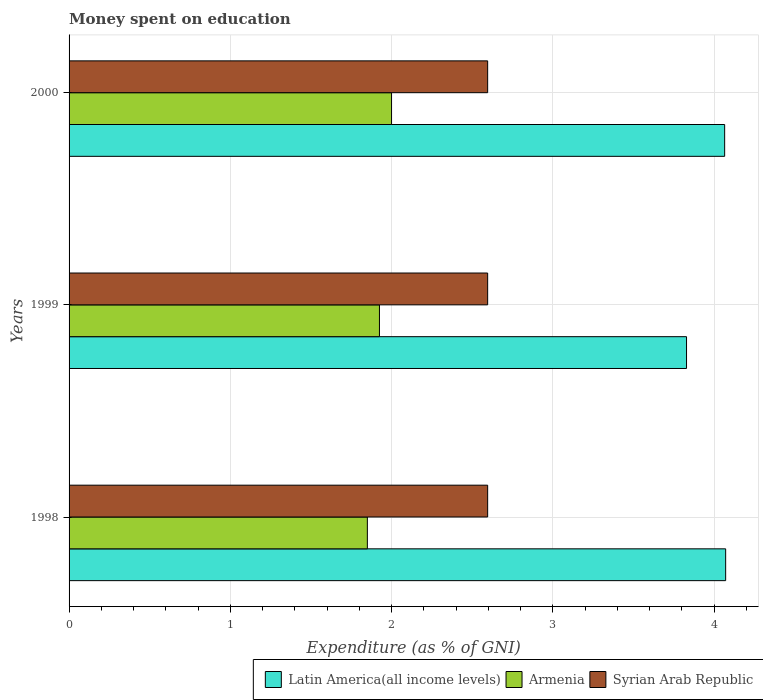How many different coloured bars are there?
Provide a short and direct response. 3. Are the number of bars on each tick of the Y-axis equal?
Make the answer very short. Yes. How many bars are there on the 3rd tick from the top?
Your answer should be very brief. 3. In how many cases, is the number of bars for a given year not equal to the number of legend labels?
Keep it short and to the point. 0. What is the amount of money spent on education in Syrian Arab Republic in 1998?
Your response must be concise. 2.6. Across all years, what is the maximum amount of money spent on education in Armenia?
Keep it short and to the point. 2. Across all years, what is the minimum amount of money spent on education in Latin America(all income levels)?
Offer a terse response. 3.83. In which year was the amount of money spent on education in Syrian Arab Republic minimum?
Your response must be concise. 1998. What is the total amount of money spent on education in Syrian Arab Republic in the graph?
Your answer should be compact. 7.79. What is the difference between the amount of money spent on education in Latin America(all income levels) in 1998 and that in 2000?
Your answer should be compact. 0.01. What is the difference between the amount of money spent on education in Latin America(all income levels) in 2000 and the amount of money spent on education in Armenia in 1998?
Provide a succinct answer. 2.22. What is the average amount of money spent on education in Armenia per year?
Make the answer very short. 1.92. In the year 1998, what is the difference between the amount of money spent on education in Syrian Arab Republic and amount of money spent on education in Latin America(all income levels)?
Make the answer very short. -1.48. Is the amount of money spent on education in Armenia in 1998 less than that in 2000?
Provide a short and direct response. Yes. What is the difference between the highest and the second highest amount of money spent on education in Armenia?
Offer a very short reply. 0.07. What is the difference between the highest and the lowest amount of money spent on education in Latin America(all income levels)?
Keep it short and to the point. 0.24. What does the 3rd bar from the top in 1999 represents?
Give a very brief answer. Latin America(all income levels). What does the 3rd bar from the bottom in 1999 represents?
Your answer should be very brief. Syrian Arab Republic. How many bars are there?
Your answer should be very brief. 9. How many years are there in the graph?
Your answer should be very brief. 3. What is the difference between two consecutive major ticks on the X-axis?
Your answer should be compact. 1. Are the values on the major ticks of X-axis written in scientific E-notation?
Your answer should be very brief. No. Does the graph contain any zero values?
Provide a short and direct response. No. Where does the legend appear in the graph?
Keep it short and to the point. Bottom right. What is the title of the graph?
Your answer should be compact. Money spent on education. Does "Mozambique" appear as one of the legend labels in the graph?
Offer a terse response. No. What is the label or title of the X-axis?
Your answer should be compact. Expenditure (as % of GNI). What is the label or title of the Y-axis?
Offer a very short reply. Years. What is the Expenditure (as % of GNI) of Latin America(all income levels) in 1998?
Provide a succinct answer. 4.07. What is the Expenditure (as % of GNI) of Armenia in 1998?
Ensure brevity in your answer.  1.85. What is the Expenditure (as % of GNI) of Syrian Arab Republic in 1998?
Keep it short and to the point. 2.6. What is the Expenditure (as % of GNI) in Latin America(all income levels) in 1999?
Your answer should be very brief. 3.83. What is the Expenditure (as % of GNI) of Armenia in 1999?
Provide a short and direct response. 1.92. What is the Expenditure (as % of GNI) in Syrian Arab Republic in 1999?
Keep it short and to the point. 2.6. What is the Expenditure (as % of GNI) of Latin America(all income levels) in 2000?
Offer a terse response. 4.07. What is the Expenditure (as % of GNI) of Armenia in 2000?
Keep it short and to the point. 2. What is the Expenditure (as % of GNI) in Syrian Arab Republic in 2000?
Your answer should be compact. 2.6. Across all years, what is the maximum Expenditure (as % of GNI) in Latin America(all income levels)?
Your response must be concise. 4.07. Across all years, what is the maximum Expenditure (as % of GNI) in Armenia?
Keep it short and to the point. 2. Across all years, what is the maximum Expenditure (as % of GNI) of Syrian Arab Republic?
Make the answer very short. 2.6. Across all years, what is the minimum Expenditure (as % of GNI) of Latin America(all income levels)?
Keep it short and to the point. 3.83. Across all years, what is the minimum Expenditure (as % of GNI) in Armenia?
Your answer should be very brief. 1.85. Across all years, what is the minimum Expenditure (as % of GNI) of Syrian Arab Republic?
Make the answer very short. 2.6. What is the total Expenditure (as % of GNI) of Latin America(all income levels) in the graph?
Provide a short and direct response. 11.97. What is the total Expenditure (as % of GNI) of Armenia in the graph?
Offer a very short reply. 5.78. What is the total Expenditure (as % of GNI) in Syrian Arab Republic in the graph?
Your response must be concise. 7.79. What is the difference between the Expenditure (as % of GNI) of Latin America(all income levels) in 1998 and that in 1999?
Keep it short and to the point. 0.24. What is the difference between the Expenditure (as % of GNI) of Armenia in 1998 and that in 1999?
Give a very brief answer. -0.07. What is the difference between the Expenditure (as % of GNI) in Latin America(all income levels) in 1998 and that in 2000?
Provide a succinct answer. 0.01. What is the difference between the Expenditure (as % of GNI) in Armenia in 1998 and that in 2000?
Your answer should be very brief. -0.15. What is the difference between the Expenditure (as % of GNI) of Latin America(all income levels) in 1999 and that in 2000?
Ensure brevity in your answer.  -0.24. What is the difference between the Expenditure (as % of GNI) in Armenia in 1999 and that in 2000?
Offer a very short reply. -0.07. What is the difference between the Expenditure (as % of GNI) of Latin America(all income levels) in 1998 and the Expenditure (as % of GNI) of Armenia in 1999?
Ensure brevity in your answer.  2.15. What is the difference between the Expenditure (as % of GNI) in Latin America(all income levels) in 1998 and the Expenditure (as % of GNI) in Syrian Arab Republic in 1999?
Your answer should be very brief. 1.48. What is the difference between the Expenditure (as % of GNI) of Armenia in 1998 and the Expenditure (as % of GNI) of Syrian Arab Republic in 1999?
Offer a terse response. -0.75. What is the difference between the Expenditure (as % of GNI) in Latin America(all income levels) in 1998 and the Expenditure (as % of GNI) in Armenia in 2000?
Offer a terse response. 2.07. What is the difference between the Expenditure (as % of GNI) in Latin America(all income levels) in 1998 and the Expenditure (as % of GNI) in Syrian Arab Republic in 2000?
Your response must be concise. 1.48. What is the difference between the Expenditure (as % of GNI) of Armenia in 1998 and the Expenditure (as % of GNI) of Syrian Arab Republic in 2000?
Give a very brief answer. -0.75. What is the difference between the Expenditure (as % of GNI) of Latin America(all income levels) in 1999 and the Expenditure (as % of GNI) of Armenia in 2000?
Provide a succinct answer. 1.83. What is the difference between the Expenditure (as % of GNI) of Latin America(all income levels) in 1999 and the Expenditure (as % of GNI) of Syrian Arab Republic in 2000?
Provide a short and direct response. 1.23. What is the difference between the Expenditure (as % of GNI) in Armenia in 1999 and the Expenditure (as % of GNI) in Syrian Arab Republic in 2000?
Your response must be concise. -0.67. What is the average Expenditure (as % of GNI) of Latin America(all income levels) per year?
Keep it short and to the point. 3.99. What is the average Expenditure (as % of GNI) of Armenia per year?
Keep it short and to the point. 1.93. What is the average Expenditure (as % of GNI) in Syrian Arab Republic per year?
Your answer should be compact. 2.6. In the year 1998, what is the difference between the Expenditure (as % of GNI) of Latin America(all income levels) and Expenditure (as % of GNI) of Armenia?
Your answer should be very brief. 2.22. In the year 1998, what is the difference between the Expenditure (as % of GNI) in Latin America(all income levels) and Expenditure (as % of GNI) in Syrian Arab Republic?
Your answer should be compact. 1.48. In the year 1998, what is the difference between the Expenditure (as % of GNI) in Armenia and Expenditure (as % of GNI) in Syrian Arab Republic?
Offer a very short reply. -0.75. In the year 1999, what is the difference between the Expenditure (as % of GNI) of Latin America(all income levels) and Expenditure (as % of GNI) of Armenia?
Ensure brevity in your answer.  1.9. In the year 1999, what is the difference between the Expenditure (as % of GNI) in Latin America(all income levels) and Expenditure (as % of GNI) in Syrian Arab Republic?
Keep it short and to the point. 1.23. In the year 1999, what is the difference between the Expenditure (as % of GNI) of Armenia and Expenditure (as % of GNI) of Syrian Arab Republic?
Provide a succinct answer. -0.67. In the year 2000, what is the difference between the Expenditure (as % of GNI) of Latin America(all income levels) and Expenditure (as % of GNI) of Armenia?
Your answer should be compact. 2.07. In the year 2000, what is the difference between the Expenditure (as % of GNI) in Latin America(all income levels) and Expenditure (as % of GNI) in Syrian Arab Republic?
Offer a very short reply. 1.47. In the year 2000, what is the difference between the Expenditure (as % of GNI) of Armenia and Expenditure (as % of GNI) of Syrian Arab Republic?
Offer a very short reply. -0.6. What is the ratio of the Expenditure (as % of GNI) of Latin America(all income levels) in 1998 to that in 1999?
Provide a short and direct response. 1.06. What is the ratio of the Expenditure (as % of GNI) in Syrian Arab Republic in 1998 to that in 1999?
Keep it short and to the point. 1. What is the ratio of the Expenditure (as % of GNI) in Armenia in 1998 to that in 2000?
Your answer should be very brief. 0.93. What is the ratio of the Expenditure (as % of GNI) of Syrian Arab Republic in 1998 to that in 2000?
Provide a succinct answer. 1. What is the ratio of the Expenditure (as % of GNI) of Latin America(all income levels) in 1999 to that in 2000?
Your response must be concise. 0.94. What is the ratio of the Expenditure (as % of GNI) in Armenia in 1999 to that in 2000?
Offer a very short reply. 0.96. What is the difference between the highest and the second highest Expenditure (as % of GNI) in Latin America(all income levels)?
Keep it short and to the point. 0.01. What is the difference between the highest and the second highest Expenditure (as % of GNI) of Armenia?
Your response must be concise. 0.07. What is the difference between the highest and the second highest Expenditure (as % of GNI) in Syrian Arab Republic?
Provide a succinct answer. 0. What is the difference between the highest and the lowest Expenditure (as % of GNI) of Latin America(all income levels)?
Your answer should be very brief. 0.24. 